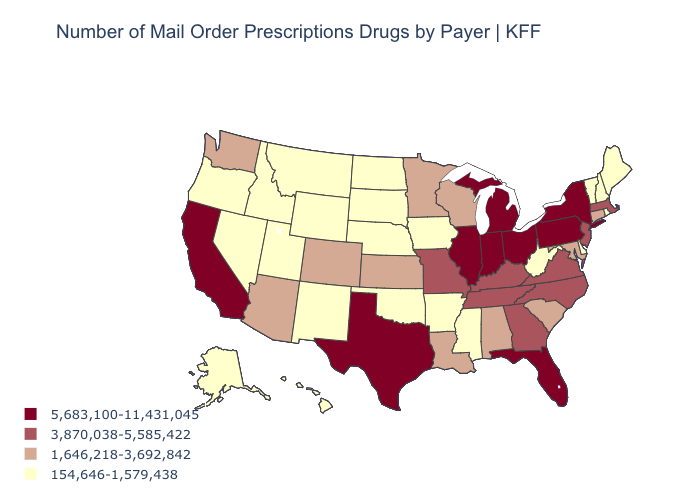Among the states that border Florida , which have the lowest value?
Quick response, please. Alabama. Is the legend a continuous bar?
Write a very short answer. No. Does Connecticut have the lowest value in the Northeast?
Answer briefly. No. Name the states that have a value in the range 3,870,038-5,585,422?
Quick response, please. Georgia, Kentucky, Massachusetts, Missouri, New Jersey, North Carolina, Tennessee, Virginia. Which states have the highest value in the USA?
Give a very brief answer. California, Florida, Illinois, Indiana, Michigan, New York, Ohio, Pennsylvania, Texas. Does Arkansas have a lower value than Michigan?
Concise answer only. Yes. What is the value of New Hampshire?
Concise answer only. 154,646-1,579,438. Among the states that border Oregon , which have the highest value?
Keep it brief. California. Does New Jersey have the lowest value in the USA?
Concise answer only. No. Name the states that have a value in the range 3,870,038-5,585,422?
Concise answer only. Georgia, Kentucky, Massachusetts, Missouri, New Jersey, North Carolina, Tennessee, Virginia. What is the highest value in states that border North Dakota?
Be succinct. 1,646,218-3,692,842. Does Minnesota have the lowest value in the USA?
Short answer required. No. Among the states that border South Dakota , which have the lowest value?
Answer briefly. Iowa, Montana, Nebraska, North Dakota, Wyoming. Which states have the lowest value in the West?
Answer briefly. Alaska, Hawaii, Idaho, Montana, Nevada, New Mexico, Oregon, Utah, Wyoming. 